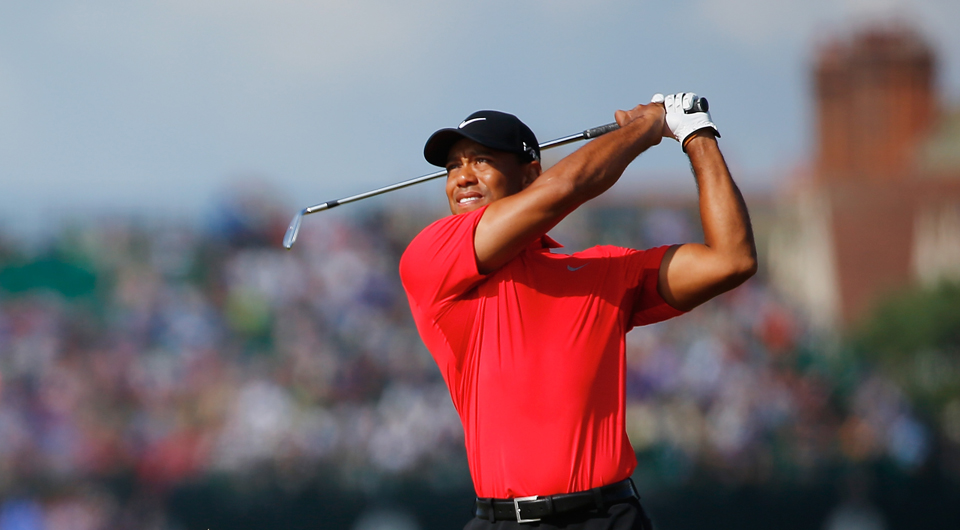Describe this image as if it were part of a futuristic virtual reality sports event. In the world of 2050, sporting events have transcended physical boundaries. This image captures a scene from a virtual reality golf tournament, where spectators from around the world, connected via VR headsets, experience the game as if they are right there on the green. The golfer, equipped with a suit that translates their real-world movements into the digital realm, swings with precision. The virtual crowd, rendered in lifelike detail, reacts in real-time, their cheers creating an immersive soundscape. Holographic visuals enhance the action, displaying real-time statistics, swing analytics, and immersive replays. This new era of sports blends the line between the physical and digital, bringing fans closer to the action than ever before. 